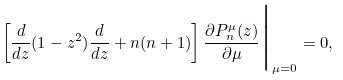<formula> <loc_0><loc_0><loc_500><loc_500>\left [ \frac { d } { d z } ( 1 - z ^ { 2 } ) \frac { d } { d z } + n ( n + 1 ) \right ] \frac { \partial P _ { n } ^ { \mu } ( z ) } { \partial \mu } \Big | _ { \mu = 0 } = 0 ,</formula> 